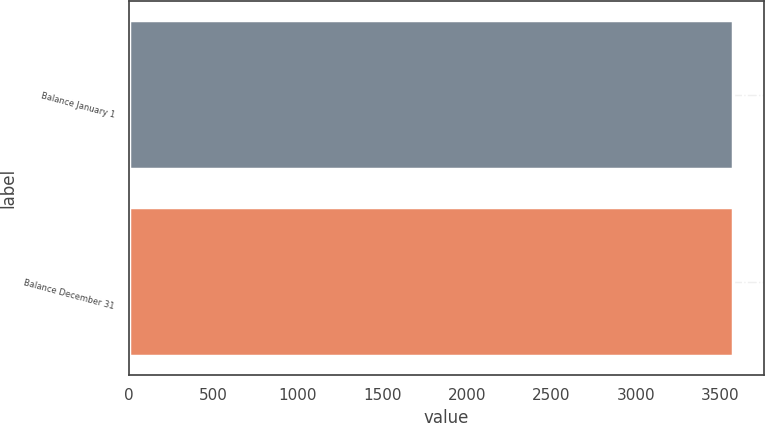<chart> <loc_0><loc_0><loc_500><loc_500><bar_chart><fcel>Balance January 1<fcel>Balance December 31<nl><fcel>3577<fcel>3577.1<nl></chart> 